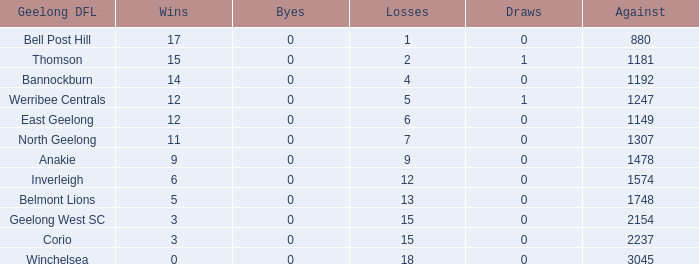What is the lowest number of wins where the byes are less than 0? None. 